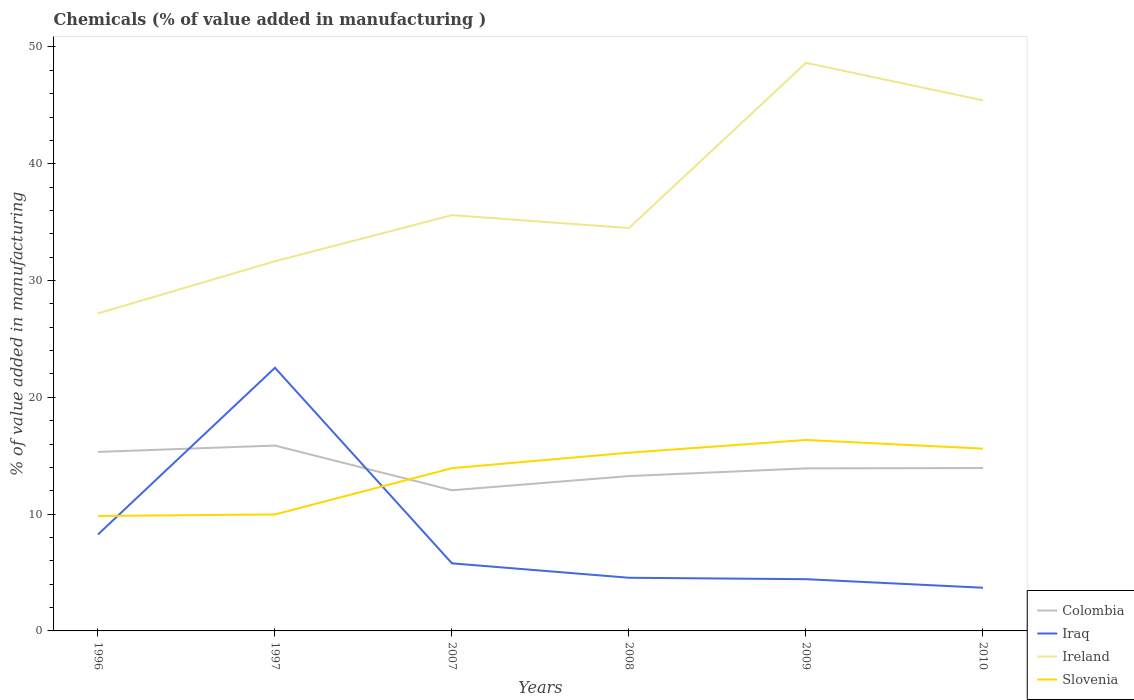Is the number of lines equal to the number of legend labels?
Offer a terse response. Yes. Across all years, what is the maximum value added in manufacturing chemicals in Colombia?
Offer a terse response. 12.04. What is the total value added in manufacturing chemicals in Colombia in the graph?
Your answer should be compact. -1.22. What is the difference between the highest and the second highest value added in manufacturing chemicals in Slovenia?
Make the answer very short. 6.51. What is the difference between the highest and the lowest value added in manufacturing chemicals in Colombia?
Your answer should be very brief. 2. Is the value added in manufacturing chemicals in Ireland strictly greater than the value added in manufacturing chemicals in Iraq over the years?
Ensure brevity in your answer.  No. Are the values on the major ticks of Y-axis written in scientific E-notation?
Provide a succinct answer. No. What is the title of the graph?
Your answer should be compact. Chemicals (% of value added in manufacturing ). Does "Kuwait" appear as one of the legend labels in the graph?
Your response must be concise. No. What is the label or title of the X-axis?
Ensure brevity in your answer.  Years. What is the label or title of the Y-axis?
Your answer should be compact. % of value added in manufacturing. What is the % of value added in manufacturing in Colombia in 1996?
Your answer should be very brief. 15.33. What is the % of value added in manufacturing of Iraq in 1996?
Offer a very short reply. 8.26. What is the % of value added in manufacturing of Ireland in 1996?
Your response must be concise. 27.19. What is the % of value added in manufacturing in Slovenia in 1996?
Offer a very short reply. 9.84. What is the % of value added in manufacturing of Colombia in 1997?
Make the answer very short. 15.87. What is the % of value added in manufacturing of Iraq in 1997?
Offer a very short reply. 22.53. What is the % of value added in manufacturing in Ireland in 1997?
Make the answer very short. 31.65. What is the % of value added in manufacturing in Slovenia in 1997?
Your answer should be very brief. 9.97. What is the % of value added in manufacturing in Colombia in 2007?
Offer a terse response. 12.04. What is the % of value added in manufacturing in Iraq in 2007?
Keep it short and to the point. 5.79. What is the % of value added in manufacturing of Ireland in 2007?
Make the answer very short. 35.6. What is the % of value added in manufacturing of Slovenia in 2007?
Your answer should be very brief. 13.93. What is the % of value added in manufacturing in Colombia in 2008?
Provide a succinct answer. 13.26. What is the % of value added in manufacturing in Iraq in 2008?
Give a very brief answer. 4.55. What is the % of value added in manufacturing in Ireland in 2008?
Your answer should be very brief. 34.49. What is the % of value added in manufacturing in Slovenia in 2008?
Ensure brevity in your answer.  15.26. What is the % of value added in manufacturing of Colombia in 2009?
Provide a succinct answer. 13.92. What is the % of value added in manufacturing of Iraq in 2009?
Offer a terse response. 4.43. What is the % of value added in manufacturing in Ireland in 2009?
Make the answer very short. 48.64. What is the % of value added in manufacturing in Slovenia in 2009?
Offer a terse response. 16.35. What is the % of value added in manufacturing in Colombia in 2010?
Keep it short and to the point. 13.95. What is the % of value added in manufacturing of Iraq in 2010?
Keep it short and to the point. 3.7. What is the % of value added in manufacturing of Ireland in 2010?
Ensure brevity in your answer.  45.43. What is the % of value added in manufacturing in Slovenia in 2010?
Provide a succinct answer. 15.61. Across all years, what is the maximum % of value added in manufacturing in Colombia?
Ensure brevity in your answer.  15.87. Across all years, what is the maximum % of value added in manufacturing of Iraq?
Provide a succinct answer. 22.53. Across all years, what is the maximum % of value added in manufacturing in Ireland?
Your answer should be very brief. 48.64. Across all years, what is the maximum % of value added in manufacturing of Slovenia?
Provide a short and direct response. 16.35. Across all years, what is the minimum % of value added in manufacturing in Colombia?
Your answer should be compact. 12.04. Across all years, what is the minimum % of value added in manufacturing of Iraq?
Offer a very short reply. 3.7. Across all years, what is the minimum % of value added in manufacturing in Ireland?
Offer a very short reply. 27.19. Across all years, what is the minimum % of value added in manufacturing of Slovenia?
Ensure brevity in your answer.  9.84. What is the total % of value added in manufacturing in Colombia in the graph?
Provide a succinct answer. 84.36. What is the total % of value added in manufacturing in Iraq in the graph?
Offer a very short reply. 49.25. What is the total % of value added in manufacturing of Ireland in the graph?
Your answer should be very brief. 223. What is the total % of value added in manufacturing in Slovenia in the graph?
Your answer should be very brief. 80.97. What is the difference between the % of value added in manufacturing of Colombia in 1996 and that in 1997?
Your response must be concise. -0.54. What is the difference between the % of value added in manufacturing in Iraq in 1996 and that in 1997?
Your answer should be very brief. -14.27. What is the difference between the % of value added in manufacturing in Ireland in 1996 and that in 1997?
Provide a short and direct response. -4.47. What is the difference between the % of value added in manufacturing in Slovenia in 1996 and that in 1997?
Provide a succinct answer. -0.13. What is the difference between the % of value added in manufacturing of Colombia in 1996 and that in 2007?
Your response must be concise. 3.28. What is the difference between the % of value added in manufacturing of Iraq in 1996 and that in 2007?
Your response must be concise. 2.47. What is the difference between the % of value added in manufacturing of Ireland in 1996 and that in 2007?
Provide a succinct answer. -8.41. What is the difference between the % of value added in manufacturing of Slovenia in 1996 and that in 2007?
Offer a terse response. -4.09. What is the difference between the % of value added in manufacturing of Colombia in 1996 and that in 2008?
Ensure brevity in your answer.  2.07. What is the difference between the % of value added in manufacturing of Iraq in 1996 and that in 2008?
Provide a short and direct response. 3.71. What is the difference between the % of value added in manufacturing of Ireland in 1996 and that in 2008?
Your answer should be compact. -7.31. What is the difference between the % of value added in manufacturing in Slovenia in 1996 and that in 2008?
Ensure brevity in your answer.  -5.42. What is the difference between the % of value added in manufacturing of Colombia in 1996 and that in 2009?
Your answer should be compact. 1.41. What is the difference between the % of value added in manufacturing in Iraq in 1996 and that in 2009?
Offer a terse response. 3.83. What is the difference between the % of value added in manufacturing in Ireland in 1996 and that in 2009?
Ensure brevity in your answer.  -21.46. What is the difference between the % of value added in manufacturing of Slovenia in 1996 and that in 2009?
Keep it short and to the point. -6.51. What is the difference between the % of value added in manufacturing in Colombia in 1996 and that in 2010?
Provide a short and direct response. 1.38. What is the difference between the % of value added in manufacturing of Iraq in 1996 and that in 2010?
Keep it short and to the point. 4.56. What is the difference between the % of value added in manufacturing of Ireland in 1996 and that in 2010?
Make the answer very short. -18.24. What is the difference between the % of value added in manufacturing in Slovenia in 1996 and that in 2010?
Keep it short and to the point. -5.76. What is the difference between the % of value added in manufacturing of Colombia in 1997 and that in 2007?
Give a very brief answer. 3.83. What is the difference between the % of value added in manufacturing in Iraq in 1997 and that in 2007?
Ensure brevity in your answer.  16.75. What is the difference between the % of value added in manufacturing of Ireland in 1997 and that in 2007?
Make the answer very short. -3.95. What is the difference between the % of value added in manufacturing of Slovenia in 1997 and that in 2007?
Offer a terse response. -3.96. What is the difference between the % of value added in manufacturing of Colombia in 1997 and that in 2008?
Keep it short and to the point. 2.61. What is the difference between the % of value added in manufacturing in Iraq in 1997 and that in 2008?
Provide a succinct answer. 17.98. What is the difference between the % of value added in manufacturing of Ireland in 1997 and that in 2008?
Keep it short and to the point. -2.84. What is the difference between the % of value added in manufacturing in Slovenia in 1997 and that in 2008?
Offer a terse response. -5.29. What is the difference between the % of value added in manufacturing in Colombia in 1997 and that in 2009?
Provide a succinct answer. 1.95. What is the difference between the % of value added in manufacturing of Iraq in 1997 and that in 2009?
Offer a very short reply. 18.1. What is the difference between the % of value added in manufacturing of Ireland in 1997 and that in 2009?
Make the answer very short. -16.99. What is the difference between the % of value added in manufacturing in Slovenia in 1997 and that in 2009?
Your answer should be very brief. -6.38. What is the difference between the % of value added in manufacturing of Colombia in 1997 and that in 2010?
Offer a terse response. 1.92. What is the difference between the % of value added in manufacturing of Iraq in 1997 and that in 2010?
Make the answer very short. 18.83. What is the difference between the % of value added in manufacturing in Ireland in 1997 and that in 2010?
Offer a terse response. -13.77. What is the difference between the % of value added in manufacturing of Slovenia in 1997 and that in 2010?
Provide a succinct answer. -5.64. What is the difference between the % of value added in manufacturing in Colombia in 2007 and that in 2008?
Provide a short and direct response. -1.22. What is the difference between the % of value added in manufacturing of Iraq in 2007 and that in 2008?
Provide a succinct answer. 1.23. What is the difference between the % of value added in manufacturing in Ireland in 2007 and that in 2008?
Offer a terse response. 1.11. What is the difference between the % of value added in manufacturing of Slovenia in 2007 and that in 2008?
Ensure brevity in your answer.  -1.33. What is the difference between the % of value added in manufacturing of Colombia in 2007 and that in 2009?
Give a very brief answer. -1.87. What is the difference between the % of value added in manufacturing of Iraq in 2007 and that in 2009?
Your response must be concise. 1.36. What is the difference between the % of value added in manufacturing of Ireland in 2007 and that in 2009?
Give a very brief answer. -13.04. What is the difference between the % of value added in manufacturing in Slovenia in 2007 and that in 2009?
Provide a succinct answer. -2.42. What is the difference between the % of value added in manufacturing in Colombia in 2007 and that in 2010?
Give a very brief answer. -1.9. What is the difference between the % of value added in manufacturing of Iraq in 2007 and that in 2010?
Offer a terse response. 2.09. What is the difference between the % of value added in manufacturing of Ireland in 2007 and that in 2010?
Make the answer very short. -9.83. What is the difference between the % of value added in manufacturing of Slovenia in 2007 and that in 2010?
Provide a short and direct response. -1.67. What is the difference between the % of value added in manufacturing in Colombia in 2008 and that in 2009?
Provide a short and direct response. -0.66. What is the difference between the % of value added in manufacturing of Iraq in 2008 and that in 2009?
Offer a terse response. 0.12. What is the difference between the % of value added in manufacturing in Ireland in 2008 and that in 2009?
Your response must be concise. -14.15. What is the difference between the % of value added in manufacturing in Slovenia in 2008 and that in 2009?
Offer a very short reply. -1.09. What is the difference between the % of value added in manufacturing of Colombia in 2008 and that in 2010?
Make the answer very short. -0.69. What is the difference between the % of value added in manufacturing of Iraq in 2008 and that in 2010?
Provide a short and direct response. 0.85. What is the difference between the % of value added in manufacturing of Ireland in 2008 and that in 2010?
Ensure brevity in your answer.  -10.93. What is the difference between the % of value added in manufacturing in Slovenia in 2008 and that in 2010?
Ensure brevity in your answer.  -0.35. What is the difference between the % of value added in manufacturing in Colombia in 2009 and that in 2010?
Give a very brief answer. -0.03. What is the difference between the % of value added in manufacturing of Iraq in 2009 and that in 2010?
Ensure brevity in your answer.  0.73. What is the difference between the % of value added in manufacturing in Ireland in 2009 and that in 2010?
Offer a terse response. 3.22. What is the difference between the % of value added in manufacturing in Slovenia in 2009 and that in 2010?
Make the answer very short. 0.74. What is the difference between the % of value added in manufacturing in Colombia in 1996 and the % of value added in manufacturing in Iraq in 1997?
Your answer should be very brief. -7.2. What is the difference between the % of value added in manufacturing of Colombia in 1996 and the % of value added in manufacturing of Ireland in 1997?
Provide a succinct answer. -16.33. What is the difference between the % of value added in manufacturing of Colombia in 1996 and the % of value added in manufacturing of Slovenia in 1997?
Make the answer very short. 5.36. What is the difference between the % of value added in manufacturing in Iraq in 1996 and the % of value added in manufacturing in Ireland in 1997?
Your answer should be compact. -23.4. What is the difference between the % of value added in manufacturing in Iraq in 1996 and the % of value added in manufacturing in Slovenia in 1997?
Provide a succinct answer. -1.71. What is the difference between the % of value added in manufacturing of Ireland in 1996 and the % of value added in manufacturing of Slovenia in 1997?
Keep it short and to the point. 17.21. What is the difference between the % of value added in manufacturing of Colombia in 1996 and the % of value added in manufacturing of Iraq in 2007?
Make the answer very short. 9.54. What is the difference between the % of value added in manufacturing in Colombia in 1996 and the % of value added in manufacturing in Ireland in 2007?
Offer a terse response. -20.27. What is the difference between the % of value added in manufacturing of Colombia in 1996 and the % of value added in manufacturing of Slovenia in 2007?
Your response must be concise. 1.39. What is the difference between the % of value added in manufacturing in Iraq in 1996 and the % of value added in manufacturing in Ireland in 2007?
Your response must be concise. -27.34. What is the difference between the % of value added in manufacturing of Iraq in 1996 and the % of value added in manufacturing of Slovenia in 2007?
Make the answer very short. -5.68. What is the difference between the % of value added in manufacturing of Ireland in 1996 and the % of value added in manufacturing of Slovenia in 2007?
Offer a terse response. 13.25. What is the difference between the % of value added in manufacturing in Colombia in 1996 and the % of value added in manufacturing in Iraq in 2008?
Provide a succinct answer. 10.78. What is the difference between the % of value added in manufacturing in Colombia in 1996 and the % of value added in manufacturing in Ireland in 2008?
Provide a short and direct response. -19.17. What is the difference between the % of value added in manufacturing of Colombia in 1996 and the % of value added in manufacturing of Slovenia in 2008?
Provide a short and direct response. 0.07. What is the difference between the % of value added in manufacturing of Iraq in 1996 and the % of value added in manufacturing of Ireland in 2008?
Keep it short and to the point. -26.24. What is the difference between the % of value added in manufacturing of Iraq in 1996 and the % of value added in manufacturing of Slovenia in 2008?
Your answer should be very brief. -7. What is the difference between the % of value added in manufacturing of Ireland in 1996 and the % of value added in manufacturing of Slovenia in 2008?
Provide a short and direct response. 11.93. What is the difference between the % of value added in manufacturing in Colombia in 1996 and the % of value added in manufacturing in Iraq in 2009?
Keep it short and to the point. 10.9. What is the difference between the % of value added in manufacturing in Colombia in 1996 and the % of value added in manufacturing in Ireland in 2009?
Offer a very short reply. -33.31. What is the difference between the % of value added in manufacturing of Colombia in 1996 and the % of value added in manufacturing of Slovenia in 2009?
Your response must be concise. -1.02. What is the difference between the % of value added in manufacturing of Iraq in 1996 and the % of value added in manufacturing of Ireland in 2009?
Ensure brevity in your answer.  -40.38. What is the difference between the % of value added in manufacturing in Iraq in 1996 and the % of value added in manufacturing in Slovenia in 2009?
Your answer should be compact. -8.09. What is the difference between the % of value added in manufacturing in Ireland in 1996 and the % of value added in manufacturing in Slovenia in 2009?
Offer a terse response. 10.84. What is the difference between the % of value added in manufacturing of Colombia in 1996 and the % of value added in manufacturing of Iraq in 2010?
Keep it short and to the point. 11.63. What is the difference between the % of value added in manufacturing of Colombia in 1996 and the % of value added in manufacturing of Ireland in 2010?
Your response must be concise. -30.1. What is the difference between the % of value added in manufacturing of Colombia in 1996 and the % of value added in manufacturing of Slovenia in 2010?
Your answer should be very brief. -0.28. What is the difference between the % of value added in manufacturing in Iraq in 1996 and the % of value added in manufacturing in Ireland in 2010?
Offer a very short reply. -37.17. What is the difference between the % of value added in manufacturing in Iraq in 1996 and the % of value added in manufacturing in Slovenia in 2010?
Make the answer very short. -7.35. What is the difference between the % of value added in manufacturing in Ireland in 1996 and the % of value added in manufacturing in Slovenia in 2010?
Keep it short and to the point. 11.58. What is the difference between the % of value added in manufacturing in Colombia in 1997 and the % of value added in manufacturing in Iraq in 2007?
Provide a short and direct response. 10.08. What is the difference between the % of value added in manufacturing in Colombia in 1997 and the % of value added in manufacturing in Ireland in 2007?
Make the answer very short. -19.73. What is the difference between the % of value added in manufacturing in Colombia in 1997 and the % of value added in manufacturing in Slovenia in 2007?
Provide a succinct answer. 1.94. What is the difference between the % of value added in manufacturing of Iraq in 1997 and the % of value added in manufacturing of Ireland in 2007?
Keep it short and to the point. -13.07. What is the difference between the % of value added in manufacturing in Iraq in 1997 and the % of value added in manufacturing in Slovenia in 2007?
Your response must be concise. 8.6. What is the difference between the % of value added in manufacturing in Ireland in 1997 and the % of value added in manufacturing in Slovenia in 2007?
Make the answer very short. 17.72. What is the difference between the % of value added in manufacturing in Colombia in 1997 and the % of value added in manufacturing in Iraq in 2008?
Your response must be concise. 11.32. What is the difference between the % of value added in manufacturing of Colombia in 1997 and the % of value added in manufacturing of Ireland in 2008?
Your answer should be very brief. -18.62. What is the difference between the % of value added in manufacturing in Colombia in 1997 and the % of value added in manufacturing in Slovenia in 2008?
Make the answer very short. 0.61. What is the difference between the % of value added in manufacturing in Iraq in 1997 and the % of value added in manufacturing in Ireland in 2008?
Give a very brief answer. -11.96. What is the difference between the % of value added in manufacturing in Iraq in 1997 and the % of value added in manufacturing in Slovenia in 2008?
Provide a succinct answer. 7.27. What is the difference between the % of value added in manufacturing of Ireland in 1997 and the % of value added in manufacturing of Slovenia in 2008?
Keep it short and to the point. 16.39. What is the difference between the % of value added in manufacturing in Colombia in 1997 and the % of value added in manufacturing in Iraq in 2009?
Offer a terse response. 11.44. What is the difference between the % of value added in manufacturing of Colombia in 1997 and the % of value added in manufacturing of Ireland in 2009?
Your answer should be very brief. -32.77. What is the difference between the % of value added in manufacturing of Colombia in 1997 and the % of value added in manufacturing of Slovenia in 2009?
Give a very brief answer. -0.48. What is the difference between the % of value added in manufacturing of Iraq in 1997 and the % of value added in manufacturing of Ireland in 2009?
Offer a terse response. -26.11. What is the difference between the % of value added in manufacturing of Iraq in 1997 and the % of value added in manufacturing of Slovenia in 2009?
Make the answer very short. 6.18. What is the difference between the % of value added in manufacturing of Ireland in 1997 and the % of value added in manufacturing of Slovenia in 2009?
Make the answer very short. 15.3. What is the difference between the % of value added in manufacturing in Colombia in 1997 and the % of value added in manufacturing in Iraq in 2010?
Offer a terse response. 12.17. What is the difference between the % of value added in manufacturing of Colombia in 1997 and the % of value added in manufacturing of Ireland in 2010?
Provide a short and direct response. -29.56. What is the difference between the % of value added in manufacturing in Colombia in 1997 and the % of value added in manufacturing in Slovenia in 2010?
Give a very brief answer. 0.26. What is the difference between the % of value added in manufacturing in Iraq in 1997 and the % of value added in manufacturing in Ireland in 2010?
Keep it short and to the point. -22.89. What is the difference between the % of value added in manufacturing in Iraq in 1997 and the % of value added in manufacturing in Slovenia in 2010?
Give a very brief answer. 6.92. What is the difference between the % of value added in manufacturing in Ireland in 1997 and the % of value added in manufacturing in Slovenia in 2010?
Ensure brevity in your answer.  16.04. What is the difference between the % of value added in manufacturing of Colombia in 2007 and the % of value added in manufacturing of Iraq in 2008?
Your answer should be very brief. 7.49. What is the difference between the % of value added in manufacturing of Colombia in 2007 and the % of value added in manufacturing of Ireland in 2008?
Offer a terse response. -22.45. What is the difference between the % of value added in manufacturing in Colombia in 2007 and the % of value added in manufacturing in Slovenia in 2008?
Your response must be concise. -3.22. What is the difference between the % of value added in manufacturing of Iraq in 2007 and the % of value added in manufacturing of Ireland in 2008?
Your response must be concise. -28.71. What is the difference between the % of value added in manufacturing in Iraq in 2007 and the % of value added in manufacturing in Slovenia in 2008?
Give a very brief answer. -9.47. What is the difference between the % of value added in manufacturing of Ireland in 2007 and the % of value added in manufacturing of Slovenia in 2008?
Make the answer very short. 20.34. What is the difference between the % of value added in manufacturing of Colombia in 2007 and the % of value added in manufacturing of Iraq in 2009?
Make the answer very short. 7.61. What is the difference between the % of value added in manufacturing of Colombia in 2007 and the % of value added in manufacturing of Ireland in 2009?
Provide a short and direct response. -36.6. What is the difference between the % of value added in manufacturing in Colombia in 2007 and the % of value added in manufacturing in Slovenia in 2009?
Ensure brevity in your answer.  -4.31. What is the difference between the % of value added in manufacturing in Iraq in 2007 and the % of value added in manufacturing in Ireland in 2009?
Make the answer very short. -42.86. What is the difference between the % of value added in manufacturing in Iraq in 2007 and the % of value added in manufacturing in Slovenia in 2009?
Your answer should be very brief. -10.56. What is the difference between the % of value added in manufacturing in Ireland in 2007 and the % of value added in manufacturing in Slovenia in 2009?
Your response must be concise. 19.25. What is the difference between the % of value added in manufacturing of Colombia in 2007 and the % of value added in manufacturing of Iraq in 2010?
Provide a succinct answer. 8.35. What is the difference between the % of value added in manufacturing in Colombia in 2007 and the % of value added in manufacturing in Ireland in 2010?
Make the answer very short. -33.38. What is the difference between the % of value added in manufacturing of Colombia in 2007 and the % of value added in manufacturing of Slovenia in 2010?
Your response must be concise. -3.57. What is the difference between the % of value added in manufacturing of Iraq in 2007 and the % of value added in manufacturing of Ireland in 2010?
Offer a very short reply. -39.64. What is the difference between the % of value added in manufacturing in Iraq in 2007 and the % of value added in manufacturing in Slovenia in 2010?
Your response must be concise. -9.82. What is the difference between the % of value added in manufacturing of Ireland in 2007 and the % of value added in manufacturing of Slovenia in 2010?
Keep it short and to the point. 19.99. What is the difference between the % of value added in manufacturing of Colombia in 2008 and the % of value added in manufacturing of Iraq in 2009?
Your answer should be very brief. 8.83. What is the difference between the % of value added in manufacturing in Colombia in 2008 and the % of value added in manufacturing in Ireland in 2009?
Give a very brief answer. -35.38. What is the difference between the % of value added in manufacturing in Colombia in 2008 and the % of value added in manufacturing in Slovenia in 2009?
Keep it short and to the point. -3.09. What is the difference between the % of value added in manufacturing of Iraq in 2008 and the % of value added in manufacturing of Ireland in 2009?
Your answer should be compact. -44.09. What is the difference between the % of value added in manufacturing in Iraq in 2008 and the % of value added in manufacturing in Slovenia in 2009?
Give a very brief answer. -11.8. What is the difference between the % of value added in manufacturing in Ireland in 2008 and the % of value added in manufacturing in Slovenia in 2009?
Provide a short and direct response. 18.14. What is the difference between the % of value added in manufacturing of Colombia in 2008 and the % of value added in manufacturing of Iraq in 2010?
Provide a succinct answer. 9.56. What is the difference between the % of value added in manufacturing of Colombia in 2008 and the % of value added in manufacturing of Ireland in 2010?
Offer a very short reply. -32.17. What is the difference between the % of value added in manufacturing of Colombia in 2008 and the % of value added in manufacturing of Slovenia in 2010?
Keep it short and to the point. -2.35. What is the difference between the % of value added in manufacturing in Iraq in 2008 and the % of value added in manufacturing in Ireland in 2010?
Your answer should be compact. -40.87. What is the difference between the % of value added in manufacturing of Iraq in 2008 and the % of value added in manufacturing of Slovenia in 2010?
Your answer should be very brief. -11.06. What is the difference between the % of value added in manufacturing in Ireland in 2008 and the % of value added in manufacturing in Slovenia in 2010?
Give a very brief answer. 18.89. What is the difference between the % of value added in manufacturing in Colombia in 2009 and the % of value added in manufacturing in Iraq in 2010?
Provide a short and direct response. 10.22. What is the difference between the % of value added in manufacturing in Colombia in 2009 and the % of value added in manufacturing in Ireland in 2010?
Provide a succinct answer. -31.51. What is the difference between the % of value added in manufacturing of Colombia in 2009 and the % of value added in manufacturing of Slovenia in 2010?
Your response must be concise. -1.69. What is the difference between the % of value added in manufacturing of Iraq in 2009 and the % of value added in manufacturing of Ireland in 2010?
Offer a terse response. -41. What is the difference between the % of value added in manufacturing in Iraq in 2009 and the % of value added in manufacturing in Slovenia in 2010?
Offer a terse response. -11.18. What is the difference between the % of value added in manufacturing of Ireland in 2009 and the % of value added in manufacturing of Slovenia in 2010?
Your response must be concise. 33.03. What is the average % of value added in manufacturing of Colombia per year?
Keep it short and to the point. 14.06. What is the average % of value added in manufacturing of Iraq per year?
Ensure brevity in your answer.  8.21. What is the average % of value added in manufacturing of Ireland per year?
Keep it short and to the point. 37.17. What is the average % of value added in manufacturing in Slovenia per year?
Your response must be concise. 13.5. In the year 1996, what is the difference between the % of value added in manufacturing in Colombia and % of value added in manufacturing in Iraq?
Make the answer very short. 7.07. In the year 1996, what is the difference between the % of value added in manufacturing in Colombia and % of value added in manufacturing in Ireland?
Give a very brief answer. -11.86. In the year 1996, what is the difference between the % of value added in manufacturing of Colombia and % of value added in manufacturing of Slovenia?
Provide a succinct answer. 5.48. In the year 1996, what is the difference between the % of value added in manufacturing in Iraq and % of value added in manufacturing in Ireland?
Your answer should be compact. -18.93. In the year 1996, what is the difference between the % of value added in manufacturing in Iraq and % of value added in manufacturing in Slovenia?
Offer a terse response. -1.59. In the year 1996, what is the difference between the % of value added in manufacturing in Ireland and % of value added in manufacturing in Slovenia?
Your answer should be very brief. 17.34. In the year 1997, what is the difference between the % of value added in manufacturing of Colombia and % of value added in manufacturing of Iraq?
Make the answer very short. -6.66. In the year 1997, what is the difference between the % of value added in manufacturing in Colombia and % of value added in manufacturing in Ireland?
Offer a very short reply. -15.78. In the year 1997, what is the difference between the % of value added in manufacturing in Colombia and % of value added in manufacturing in Slovenia?
Offer a very short reply. 5.9. In the year 1997, what is the difference between the % of value added in manufacturing in Iraq and % of value added in manufacturing in Ireland?
Offer a very short reply. -9.12. In the year 1997, what is the difference between the % of value added in manufacturing in Iraq and % of value added in manufacturing in Slovenia?
Provide a short and direct response. 12.56. In the year 1997, what is the difference between the % of value added in manufacturing in Ireland and % of value added in manufacturing in Slovenia?
Your answer should be compact. 21.68. In the year 2007, what is the difference between the % of value added in manufacturing in Colombia and % of value added in manufacturing in Iraq?
Ensure brevity in your answer.  6.26. In the year 2007, what is the difference between the % of value added in manufacturing in Colombia and % of value added in manufacturing in Ireland?
Your answer should be very brief. -23.56. In the year 2007, what is the difference between the % of value added in manufacturing of Colombia and % of value added in manufacturing of Slovenia?
Keep it short and to the point. -1.89. In the year 2007, what is the difference between the % of value added in manufacturing of Iraq and % of value added in manufacturing of Ireland?
Offer a very short reply. -29.81. In the year 2007, what is the difference between the % of value added in manufacturing of Iraq and % of value added in manufacturing of Slovenia?
Give a very brief answer. -8.15. In the year 2007, what is the difference between the % of value added in manufacturing of Ireland and % of value added in manufacturing of Slovenia?
Ensure brevity in your answer.  21.66. In the year 2008, what is the difference between the % of value added in manufacturing of Colombia and % of value added in manufacturing of Iraq?
Offer a terse response. 8.71. In the year 2008, what is the difference between the % of value added in manufacturing of Colombia and % of value added in manufacturing of Ireland?
Your response must be concise. -21.23. In the year 2008, what is the difference between the % of value added in manufacturing of Colombia and % of value added in manufacturing of Slovenia?
Provide a succinct answer. -2. In the year 2008, what is the difference between the % of value added in manufacturing of Iraq and % of value added in manufacturing of Ireland?
Provide a succinct answer. -29.94. In the year 2008, what is the difference between the % of value added in manufacturing in Iraq and % of value added in manufacturing in Slovenia?
Provide a short and direct response. -10.71. In the year 2008, what is the difference between the % of value added in manufacturing of Ireland and % of value added in manufacturing of Slovenia?
Your response must be concise. 19.23. In the year 2009, what is the difference between the % of value added in manufacturing of Colombia and % of value added in manufacturing of Iraq?
Ensure brevity in your answer.  9.49. In the year 2009, what is the difference between the % of value added in manufacturing of Colombia and % of value added in manufacturing of Ireland?
Provide a succinct answer. -34.72. In the year 2009, what is the difference between the % of value added in manufacturing in Colombia and % of value added in manufacturing in Slovenia?
Offer a very short reply. -2.43. In the year 2009, what is the difference between the % of value added in manufacturing in Iraq and % of value added in manufacturing in Ireland?
Your answer should be very brief. -44.21. In the year 2009, what is the difference between the % of value added in manufacturing in Iraq and % of value added in manufacturing in Slovenia?
Provide a succinct answer. -11.92. In the year 2009, what is the difference between the % of value added in manufacturing of Ireland and % of value added in manufacturing of Slovenia?
Make the answer very short. 32.29. In the year 2010, what is the difference between the % of value added in manufacturing of Colombia and % of value added in manufacturing of Iraq?
Your answer should be very brief. 10.25. In the year 2010, what is the difference between the % of value added in manufacturing of Colombia and % of value added in manufacturing of Ireland?
Keep it short and to the point. -31.48. In the year 2010, what is the difference between the % of value added in manufacturing of Colombia and % of value added in manufacturing of Slovenia?
Offer a very short reply. -1.66. In the year 2010, what is the difference between the % of value added in manufacturing of Iraq and % of value added in manufacturing of Ireland?
Your answer should be very brief. -41.73. In the year 2010, what is the difference between the % of value added in manufacturing in Iraq and % of value added in manufacturing in Slovenia?
Ensure brevity in your answer.  -11.91. In the year 2010, what is the difference between the % of value added in manufacturing of Ireland and % of value added in manufacturing of Slovenia?
Make the answer very short. 29.82. What is the ratio of the % of value added in manufacturing in Colombia in 1996 to that in 1997?
Your answer should be compact. 0.97. What is the ratio of the % of value added in manufacturing in Iraq in 1996 to that in 1997?
Keep it short and to the point. 0.37. What is the ratio of the % of value added in manufacturing of Ireland in 1996 to that in 1997?
Give a very brief answer. 0.86. What is the ratio of the % of value added in manufacturing of Slovenia in 1996 to that in 1997?
Your answer should be very brief. 0.99. What is the ratio of the % of value added in manufacturing of Colombia in 1996 to that in 2007?
Your response must be concise. 1.27. What is the ratio of the % of value added in manufacturing in Iraq in 1996 to that in 2007?
Offer a terse response. 1.43. What is the ratio of the % of value added in manufacturing in Ireland in 1996 to that in 2007?
Provide a succinct answer. 0.76. What is the ratio of the % of value added in manufacturing of Slovenia in 1996 to that in 2007?
Give a very brief answer. 0.71. What is the ratio of the % of value added in manufacturing in Colombia in 1996 to that in 2008?
Make the answer very short. 1.16. What is the ratio of the % of value added in manufacturing in Iraq in 1996 to that in 2008?
Provide a short and direct response. 1.81. What is the ratio of the % of value added in manufacturing of Ireland in 1996 to that in 2008?
Your response must be concise. 0.79. What is the ratio of the % of value added in manufacturing in Slovenia in 1996 to that in 2008?
Give a very brief answer. 0.65. What is the ratio of the % of value added in manufacturing of Colombia in 1996 to that in 2009?
Give a very brief answer. 1.1. What is the ratio of the % of value added in manufacturing in Iraq in 1996 to that in 2009?
Give a very brief answer. 1.86. What is the ratio of the % of value added in manufacturing in Ireland in 1996 to that in 2009?
Ensure brevity in your answer.  0.56. What is the ratio of the % of value added in manufacturing of Slovenia in 1996 to that in 2009?
Provide a short and direct response. 0.6. What is the ratio of the % of value added in manufacturing of Colombia in 1996 to that in 2010?
Ensure brevity in your answer.  1.1. What is the ratio of the % of value added in manufacturing of Iraq in 1996 to that in 2010?
Offer a terse response. 2.23. What is the ratio of the % of value added in manufacturing of Ireland in 1996 to that in 2010?
Keep it short and to the point. 0.6. What is the ratio of the % of value added in manufacturing of Slovenia in 1996 to that in 2010?
Provide a short and direct response. 0.63. What is the ratio of the % of value added in manufacturing of Colombia in 1997 to that in 2007?
Keep it short and to the point. 1.32. What is the ratio of the % of value added in manufacturing in Iraq in 1997 to that in 2007?
Keep it short and to the point. 3.89. What is the ratio of the % of value added in manufacturing of Ireland in 1997 to that in 2007?
Ensure brevity in your answer.  0.89. What is the ratio of the % of value added in manufacturing in Slovenia in 1997 to that in 2007?
Keep it short and to the point. 0.72. What is the ratio of the % of value added in manufacturing of Colombia in 1997 to that in 2008?
Your response must be concise. 1.2. What is the ratio of the % of value added in manufacturing of Iraq in 1997 to that in 2008?
Offer a very short reply. 4.95. What is the ratio of the % of value added in manufacturing of Ireland in 1997 to that in 2008?
Give a very brief answer. 0.92. What is the ratio of the % of value added in manufacturing in Slovenia in 1997 to that in 2008?
Make the answer very short. 0.65. What is the ratio of the % of value added in manufacturing of Colombia in 1997 to that in 2009?
Your answer should be compact. 1.14. What is the ratio of the % of value added in manufacturing in Iraq in 1997 to that in 2009?
Give a very brief answer. 5.09. What is the ratio of the % of value added in manufacturing of Ireland in 1997 to that in 2009?
Provide a short and direct response. 0.65. What is the ratio of the % of value added in manufacturing of Slovenia in 1997 to that in 2009?
Make the answer very short. 0.61. What is the ratio of the % of value added in manufacturing in Colombia in 1997 to that in 2010?
Provide a short and direct response. 1.14. What is the ratio of the % of value added in manufacturing of Iraq in 1997 to that in 2010?
Make the answer very short. 6.09. What is the ratio of the % of value added in manufacturing of Ireland in 1997 to that in 2010?
Provide a succinct answer. 0.7. What is the ratio of the % of value added in manufacturing in Slovenia in 1997 to that in 2010?
Give a very brief answer. 0.64. What is the ratio of the % of value added in manufacturing in Colombia in 2007 to that in 2008?
Your response must be concise. 0.91. What is the ratio of the % of value added in manufacturing in Iraq in 2007 to that in 2008?
Your answer should be very brief. 1.27. What is the ratio of the % of value added in manufacturing of Ireland in 2007 to that in 2008?
Your answer should be compact. 1.03. What is the ratio of the % of value added in manufacturing in Slovenia in 2007 to that in 2008?
Keep it short and to the point. 0.91. What is the ratio of the % of value added in manufacturing of Colombia in 2007 to that in 2009?
Your answer should be very brief. 0.87. What is the ratio of the % of value added in manufacturing in Iraq in 2007 to that in 2009?
Offer a very short reply. 1.31. What is the ratio of the % of value added in manufacturing in Ireland in 2007 to that in 2009?
Make the answer very short. 0.73. What is the ratio of the % of value added in manufacturing of Slovenia in 2007 to that in 2009?
Your answer should be compact. 0.85. What is the ratio of the % of value added in manufacturing in Colombia in 2007 to that in 2010?
Your answer should be compact. 0.86. What is the ratio of the % of value added in manufacturing in Iraq in 2007 to that in 2010?
Your response must be concise. 1.56. What is the ratio of the % of value added in manufacturing of Ireland in 2007 to that in 2010?
Give a very brief answer. 0.78. What is the ratio of the % of value added in manufacturing of Slovenia in 2007 to that in 2010?
Keep it short and to the point. 0.89. What is the ratio of the % of value added in manufacturing in Colombia in 2008 to that in 2009?
Ensure brevity in your answer.  0.95. What is the ratio of the % of value added in manufacturing of Iraq in 2008 to that in 2009?
Your answer should be compact. 1.03. What is the ratio of the % of value added in manufacturing of Ireland in 2008 to that in 2009?
Your answer should be compact. 0.71. What is the ratio of the % of value added in manufacturing of Slovenia in 2008 to that in 2009?
Offer a terse response. 0.93. What is the ratio of the % of value added in manufacturing of Colombia in 2008 to that in 2010?
Keep it short and to the point. 0.95. What is the ratio of the % of value added in manufacturing in Iraq in 2008 to that in 2010?
Make the answer very short. 1.23. What is the ratio of the % of value added in manufacturing in Ireland in 2008 to that in 2010?
Make the answer very short. 0.76. What is the ratio of the % of value added in manufacturing of Slovenia in 2008 to that in 2010?
Give a very brief answer. 0.98. What is the ratio of the % of value added in manufacturing in Iraq in 2009 to that in 2010?
Provide a succinct answer. 1.2. What is the ratio of the % of value added in manufacturing in Ireland in 2009 to that in 2010?
Your response must be concise. 1.07. What is the ratio of the % of value added in manufacturing in Slovenia in 2009 to that in 2010?
Ensure brevity in your answer.  1.05. What is the difference between the highest and the second highest % of value added in manufacturing in Colombia?
Ensure brevity in your answer.  0.54. What is the difference between the highest and the second highest % of value added in manufacturing of Iraq?
Provide a succinct answer. 14.27. What is the difference between the highest and the second highest % of value added in manufacturing of Ireland?
Provide a short and direct response. 3.22. What is the difference between the highest and the second highest % of value added in manufacturing in Slovenia?
Give a very brief answer. 0.74. What is the difference between the highest and the lowest % of value added in manufacturing of Colombia?
Provide a succinct answer. 3.83. What is the difference between the highest and the lowest % of value added in manufacturing in Iraq?
Offer a very short reply. 18.83. What is the difference between the highest and the lowest % of value added in manufacturing in Ireland?
Make the answer very short. 21.46. What is the difference between the highest and the lowest % of value added in manufacturing in Slovenia?
Offer a very short reply. 6.51. 